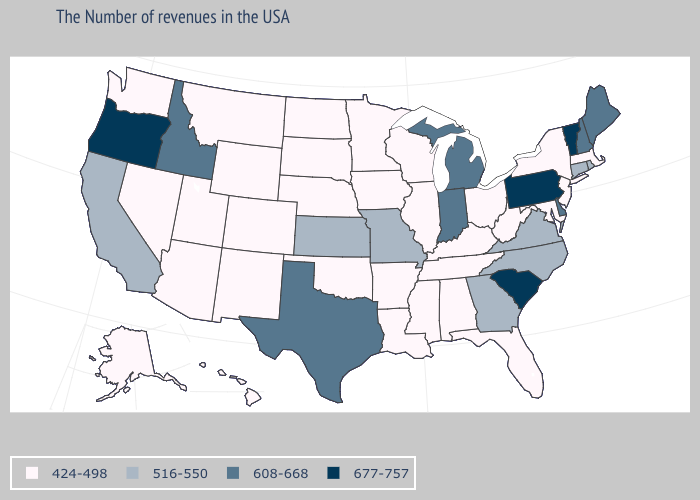Name the states that have a value in the range 516-550?
Quick response, please. Rhode Island, Connecticut, Virginia, North Carolina, Georgia, Missouri, Kansas, California. Name the states that have a value in the range 677-757?
Quick response, please. Vermont, Pennsylvania, South Carolina, Oregon. Among the states that border Ohio , which have the lowest value?
Write a very short answer. West Virginia, Kentucky. Is the legend a continuous bar?
Concise answer only. No. Among the states that border Georgia , which have the highest value?
Concise answer only. South Carolina. What is the value of Alabama?
Be succinct. 424-498. What is the lowest value in the USA?
Keep it brief. 424-498. What is the lowest value in the USA?
Keep it brief. 424-498. What is the value of New Hampshire?
Quick response, please. 608-668. What is the value of Wyoming?
Be succinct. 424-498. What is the highest value in states that border Nevada?
Concise answer only. 677-757. How many symbols are there in the legend?
Short answer required. 4. Does the map have missing data?
Give a very brief answer. No. What is the value of Missouri?
Be succinct. 516-550. Which states hav the highest value in the MidWest?
Be succinct. Michigan, Indiana. 